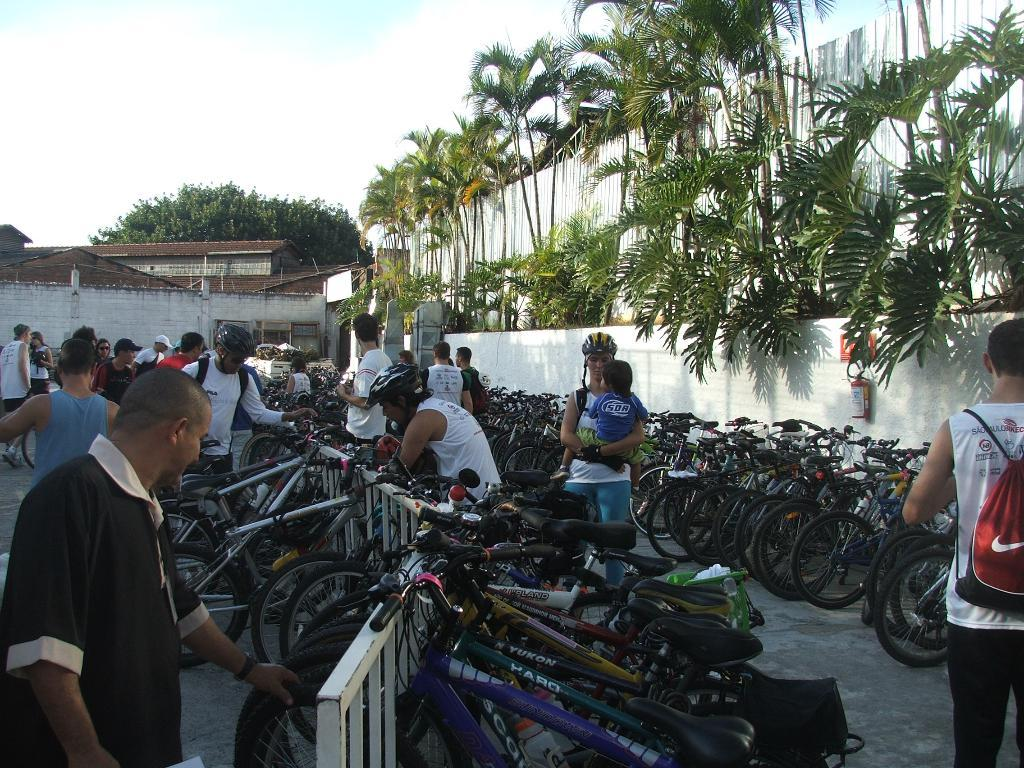How many persons are in the image? There are persons in the image. What are the persons using in the image? There are bicycles in the image. What can be seen in the background of the image? There is a building and trees in the background of the image. What is visible in the sky in the image? The sky is visible in the image. Can you hear the parent whistling in the image? There is no mention of a parent or whistling in the image, so it cannot be determined if a parent is whistling. 